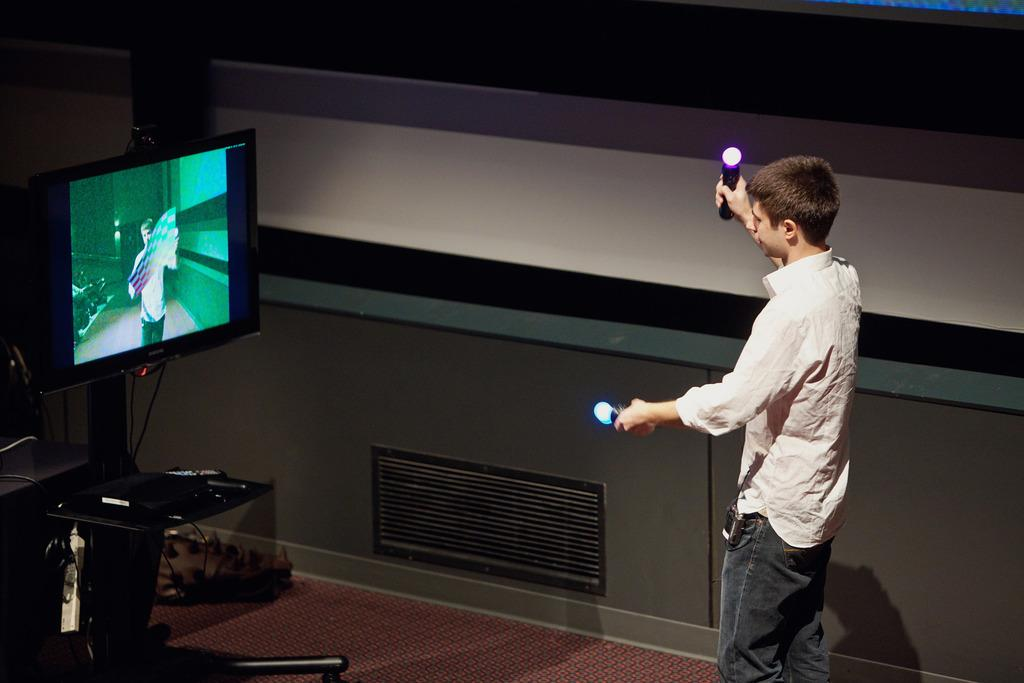What can be seen in the image? There is a person in the image. What is the person holding in their hand? The person is holding an object in their hand. What electronic device is present in the image? There is a television in the image. Where is the television placed? The television is on a stand. How many feet can be seen on the yak in the image? There is no yak present in the image, so it is not possible to determine the number of feet on a yak. 